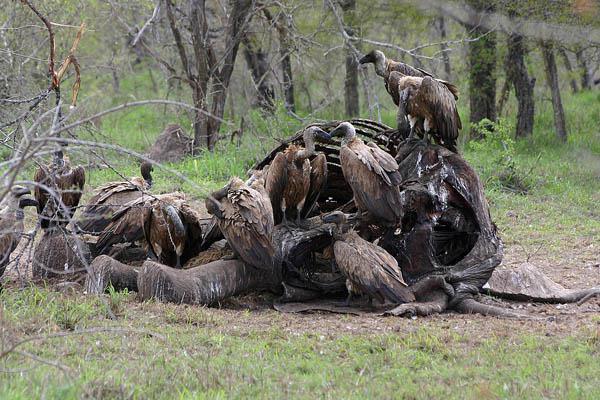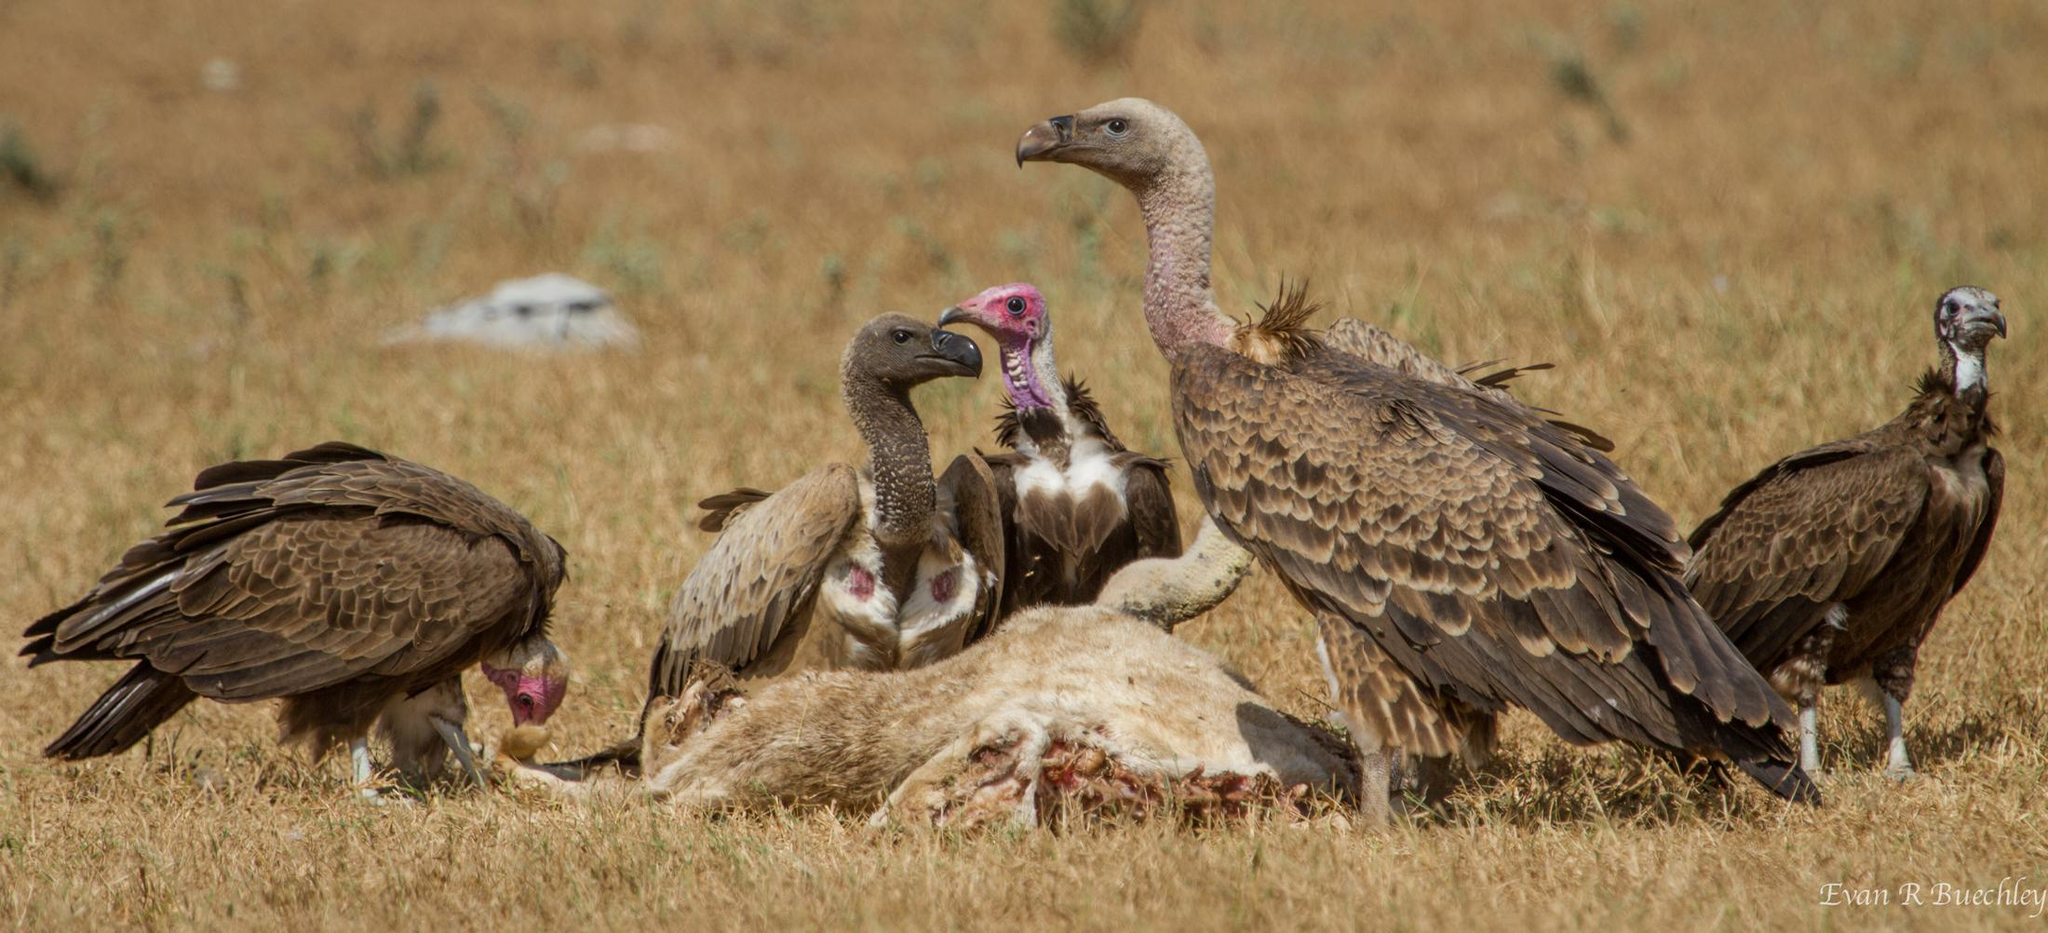The first image is the image on the left, the second image is the image on the right. For the images shown, is this caption "there is water in the image on the right" true? Answer yes or no. No. The first image is the image on the left, the second image is the image on the right. Given the left and right images, does the statement "A body of water is visible in one of the images." hold true? Answer yes or no. No. 